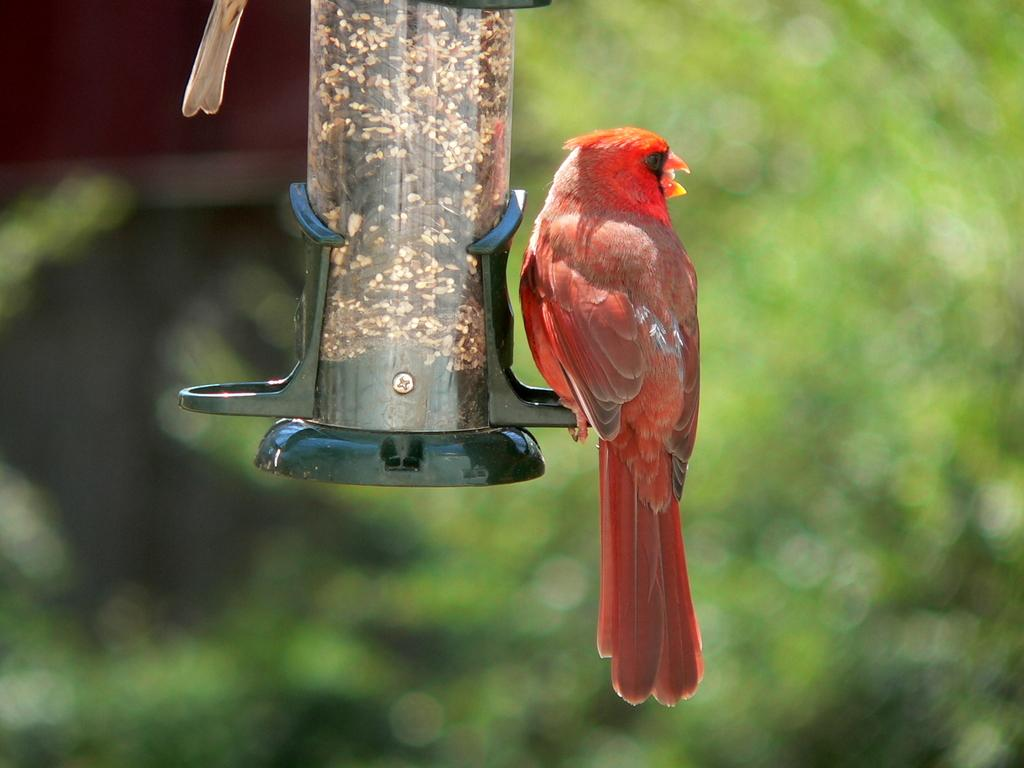What is the main object in the image? There is a bird feeder stock in the image. Can you describe any animals present in the image? There is a red color bird in the image. What type of cream can be seen being ordered by the bird in the image? There is no cream or order present in the image; it features a bird feeder stock and a red color bird. 